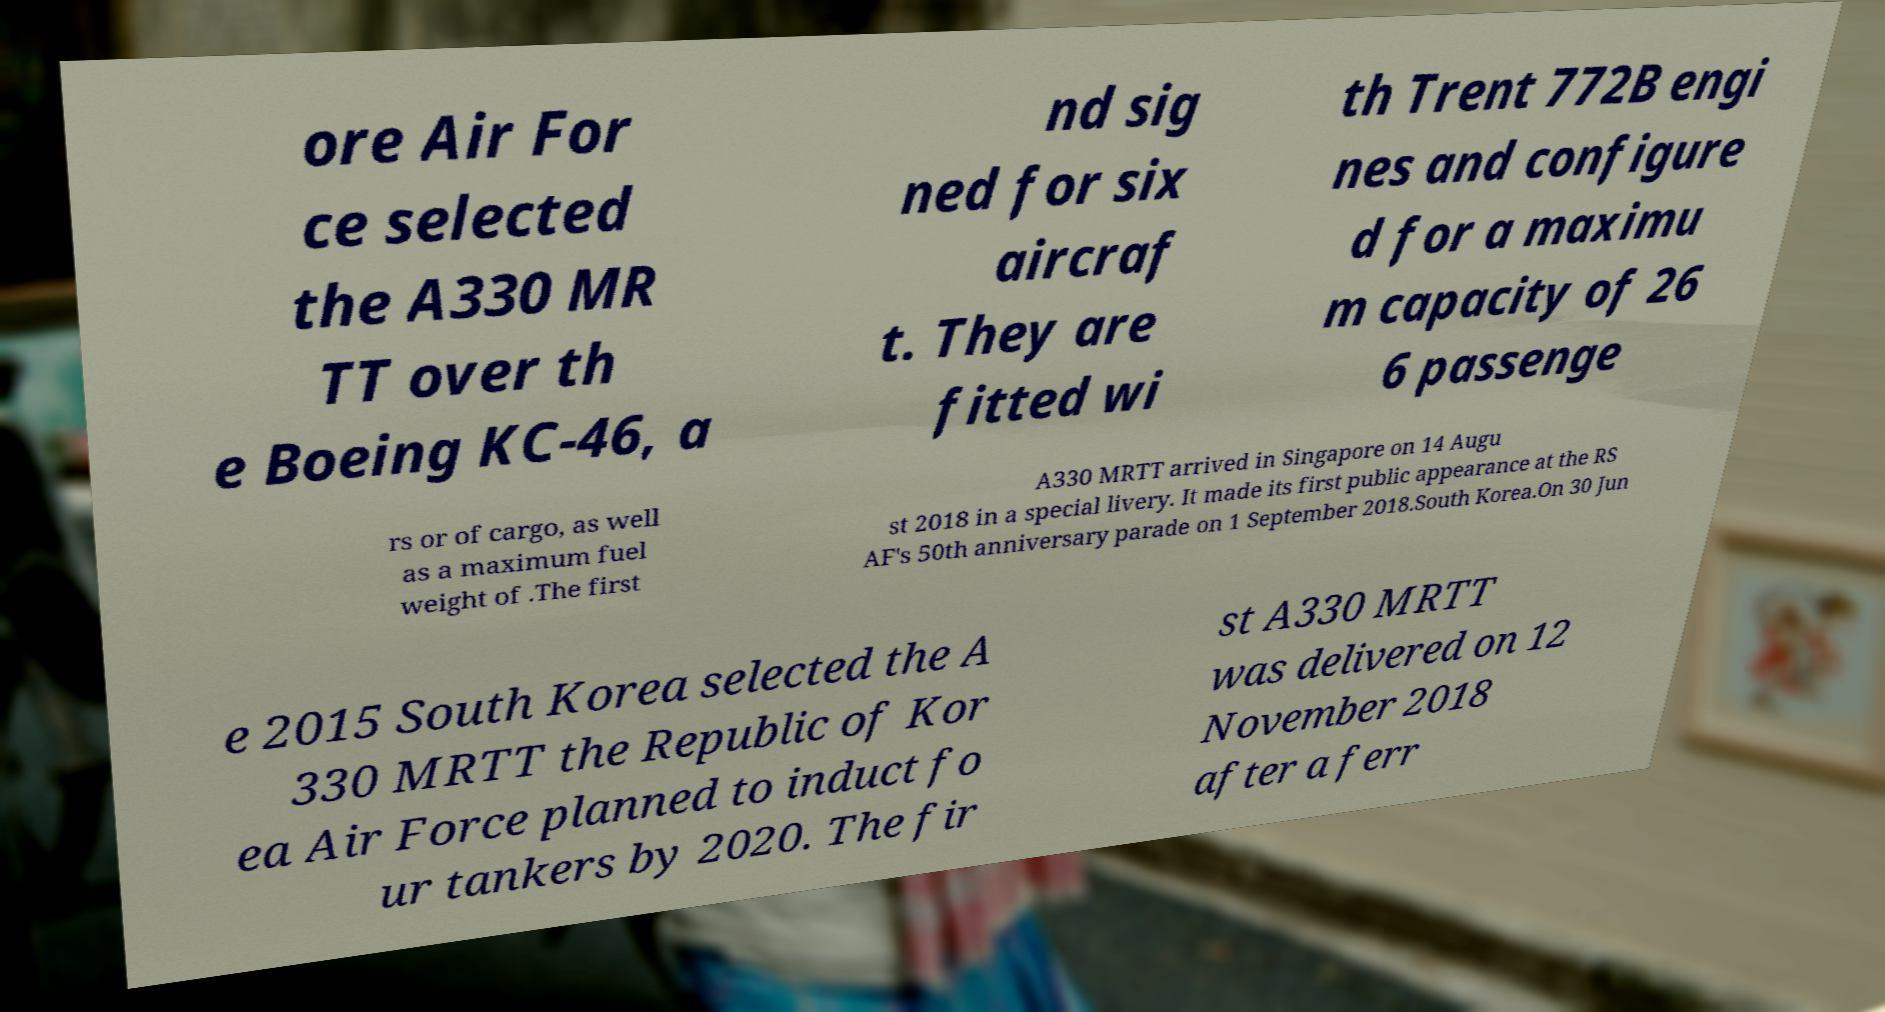What messages or text are displayed in this image? I need them in a readable, typed format. ore Air For ce selected the A330 MR TT over th e Boeing KC-46, a nd sig ned for six aircraf t. They are fitted wi th Trent 772B engi nes and configure d for a maximu m capacity of 26 6 passenge rs or of cargo, as well as a maximum fuel weight of .The first A330 MRTT arrived in Singapore on 14 Augu st 2018 in a special livery. It made its first public appearance at the RS AF's 50th anniversary parade on 1 September 2018.South Korea.On 30 Jun e 2015 South Korea selected the A 330 MRTT the Republic of Kor ea Air Force planned to induct fo ur tankers by 2020. The fir st A330 MRTT was delivered on 12 November 2018 after a ferr 